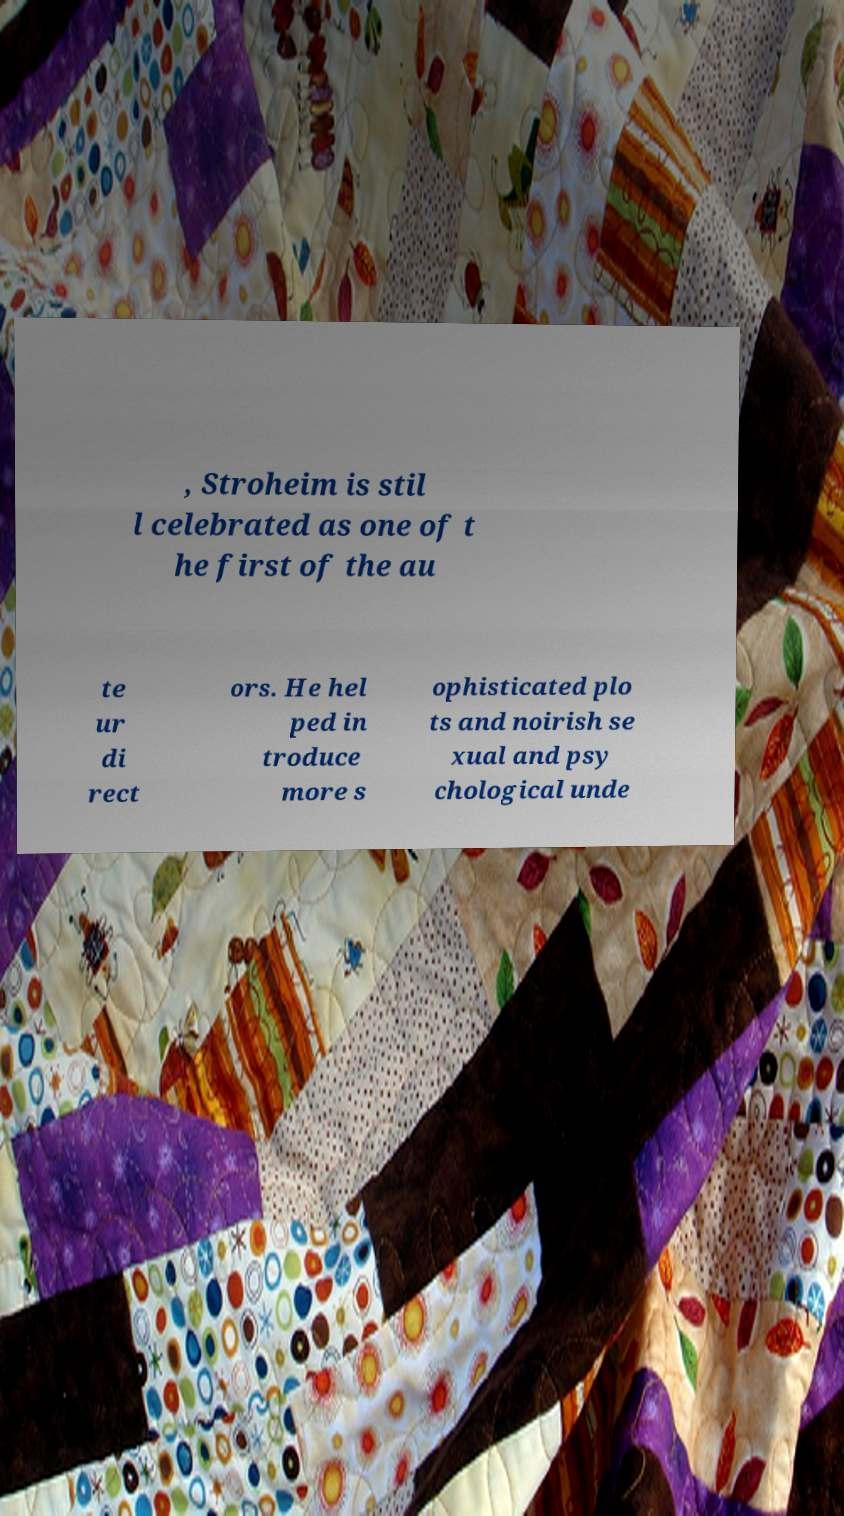Could you assist in decoding the text presented in this image and type it out clearly? , Stroheim is stil l celebrated as one of t he first of the au te ur di rect ors. He hel ped in troduce more s ophisticated plo ts and noirish se xual and psy chological unde 